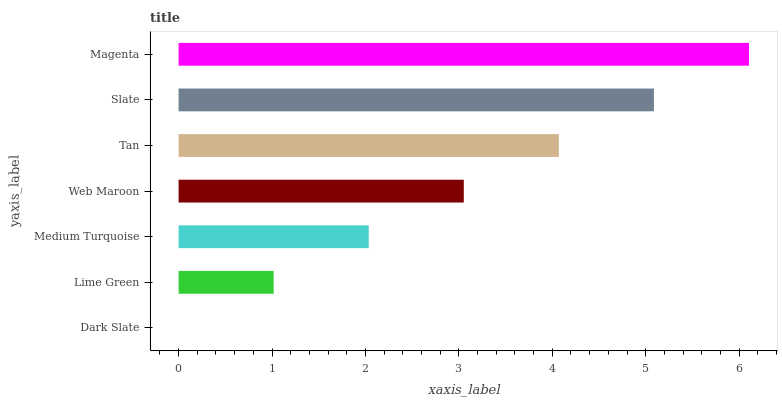Is Dark Slate the minimum?
Answer yes or no. Yes. Is Magenta the maximum?
Answer yes or no. Yes. Is Lime Green the minimum?
Answer yes or no. No. Is Lime Green the maximum?
Answer yes or no. No. Is Lime Green greater than Dark Slate?
Answer yes or no. Yes. Is Dark Slate less than Lime Green?
Answer yes or no. Yes. Is Dark Slate greater than Lime Green?
Answer yes or no. No. Is Lime Green less than Dark Slate?
Answer yes or no. No. Is Web Maroon the high median?
Answer yes or no. Yes. Is Web Maroon the low median?
Answer yes or no. Yes. Is Medium Turquoise the high median?
Answer yes or no. No. Is Slate the low median?
Answer yes or no. No. 